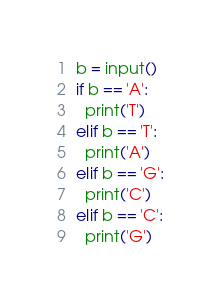Convert code to text. <code><loc_0><loc_0><loc_500><loc_500><_Python_>b = input()
if b == 'A':
  print('T')
elif b == 'T':
  print('A')
elif b == 'G':
  print('C')
elif b == 'C':
  print('G')</code> 